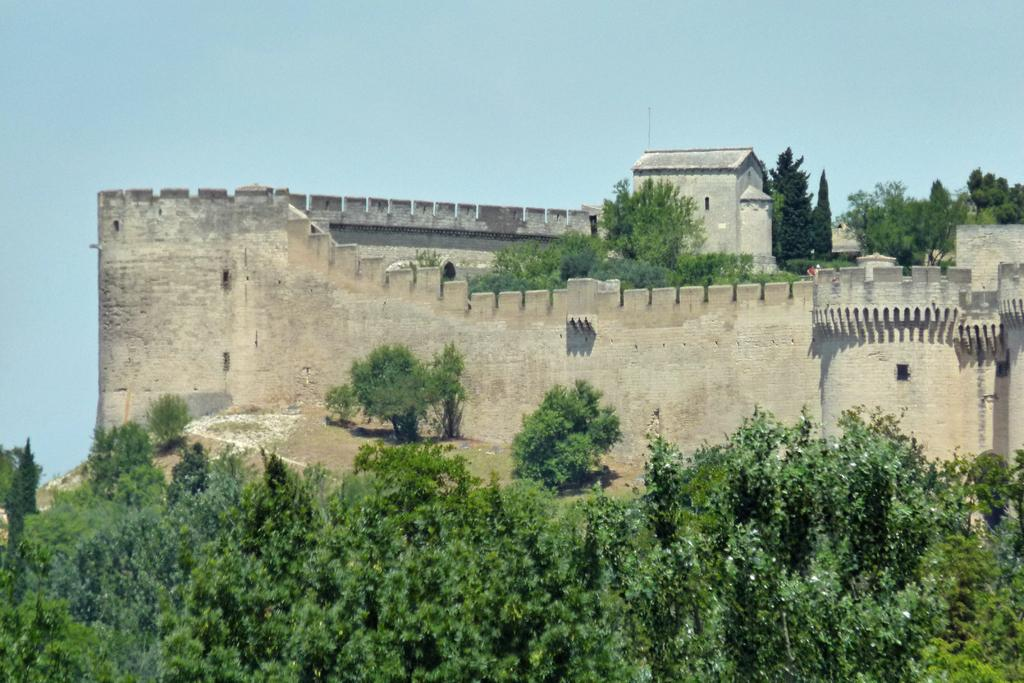What type of structure is visible in the image? There is a fort in the image. What can be seen at the bottom of the image? There are trees at the bottom of the image. Are there any trees inside the fort? Yes, there are trees inside the fort. What is the condition of the sky in the image? The sky is clear in the image. What type of tax is being discussed in the image? There is no discussion of tax in the image; it features a fort with trees and a clear sky. What is providing support for the middle of the fort? The image does not show any specific support for the middle of the fort; it only shows the structure and surrounding trees. 